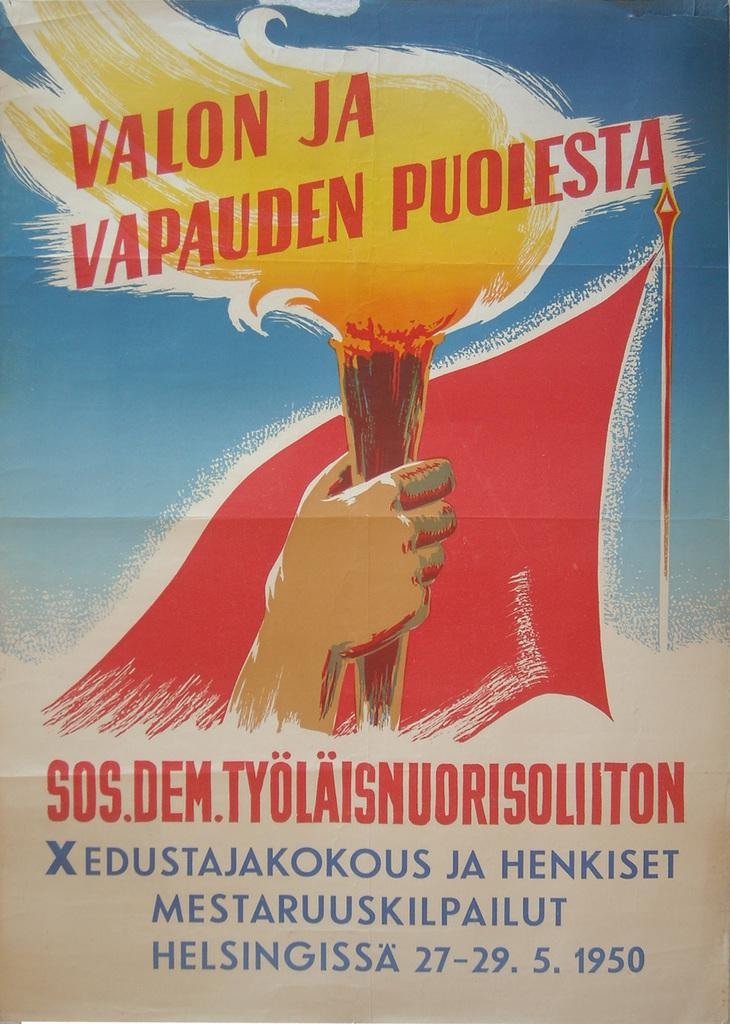<image>
Share a concise interpretation of the image provided. A poster advertises an event dated 27-29. 5. 1950. 